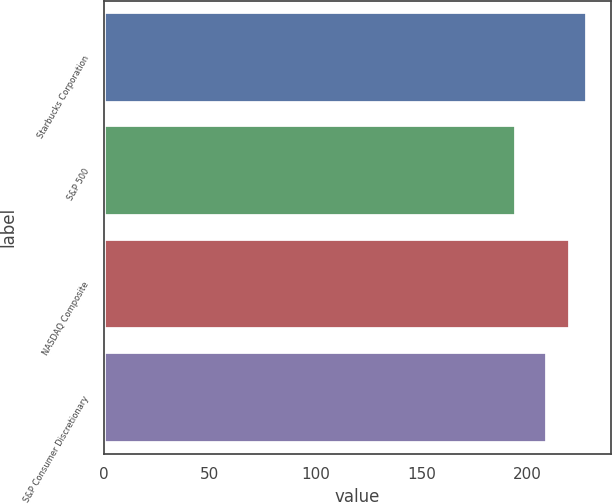Convert chart to OTSL. <chart><loc_0><loc_0><loc_500><loc_500><bar_chart><fcel>Starbucks Corporation<fcel>S&P 500<fcel>NASDAQ Composite<fcel>S&P Consumer Discretionary<nl><fcel>227.92<fcel>194.44<fcel>220.25<fcel>209.4<nl></chart> 